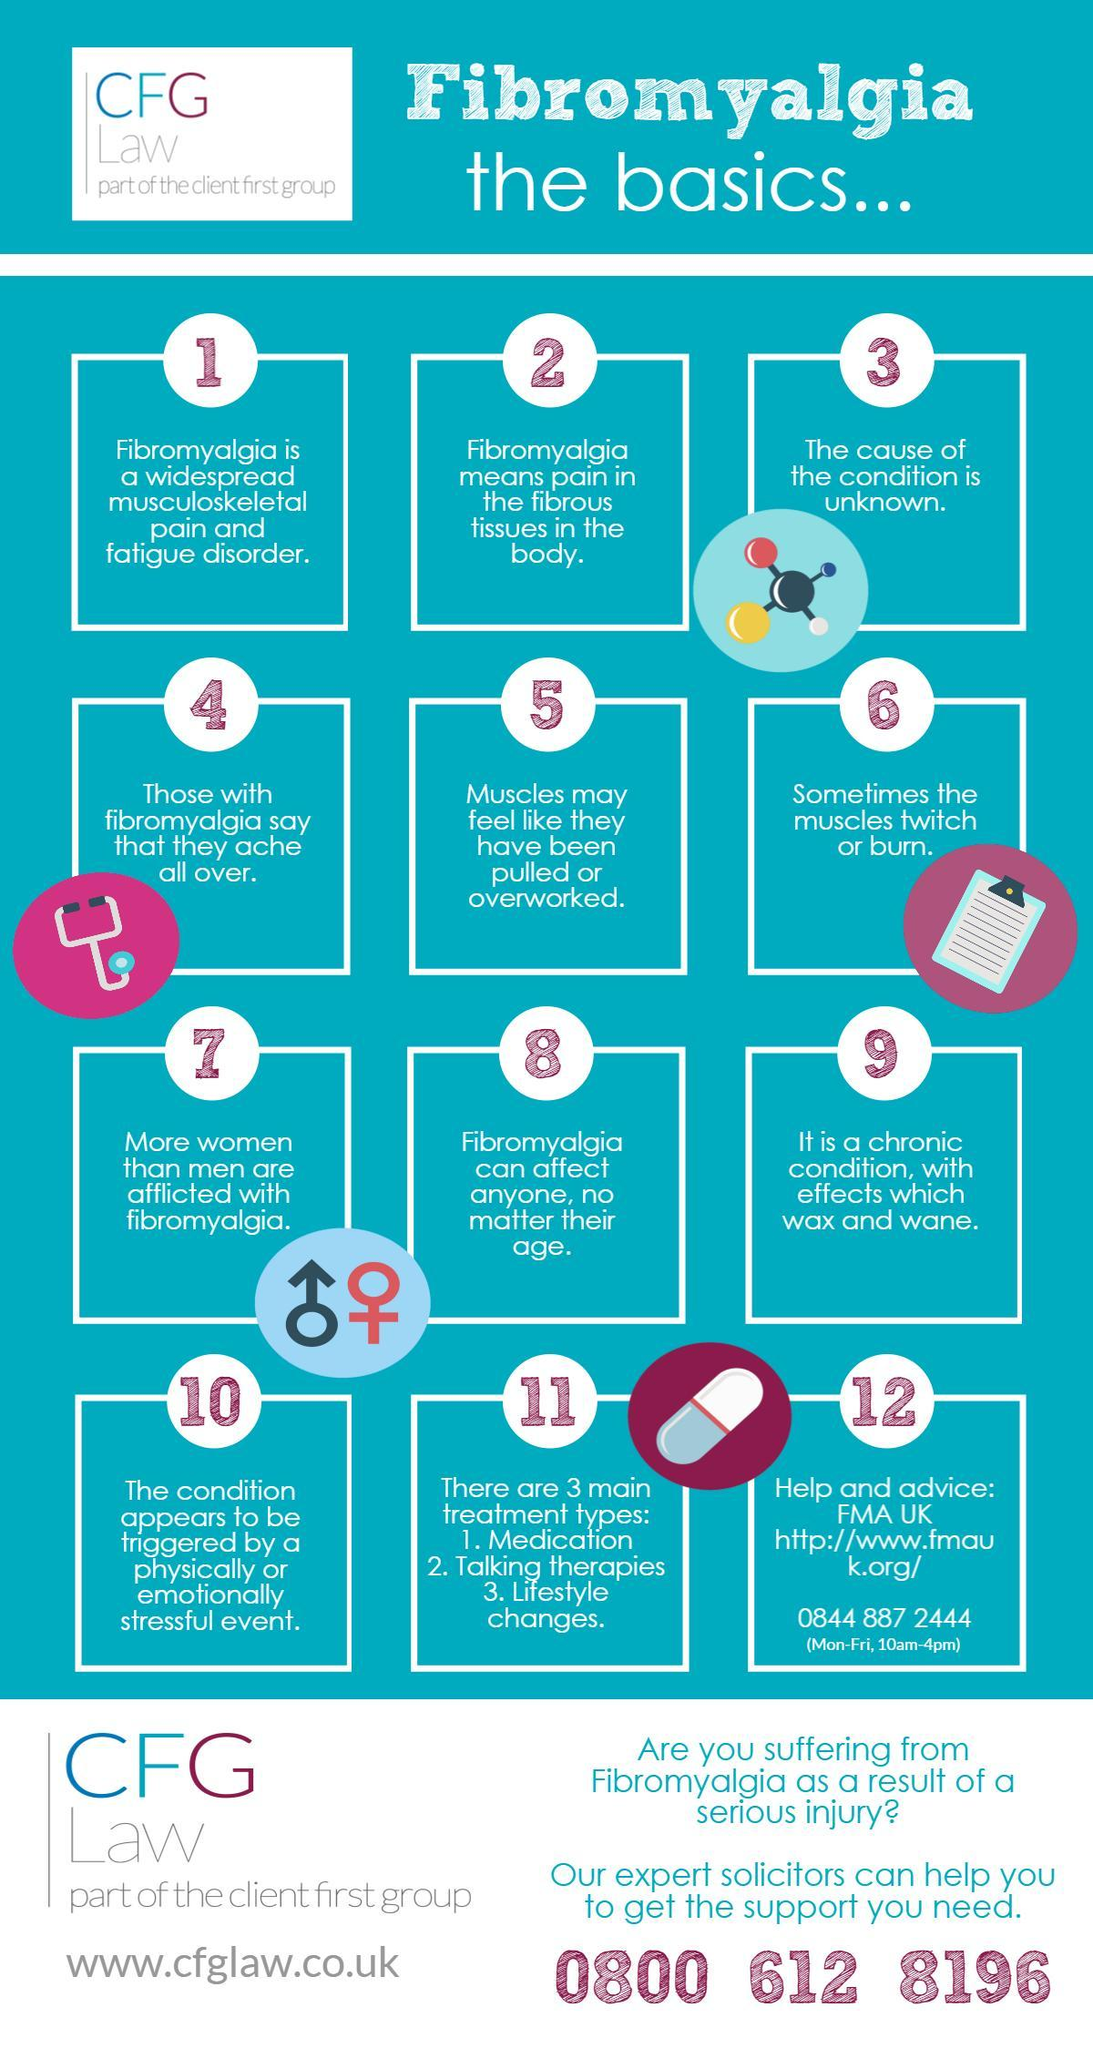Which are the ways in which Fibromyalgia is treated?
Answer the question with a short phrase. Medication, Talking Therapies, Lifestyle changes 